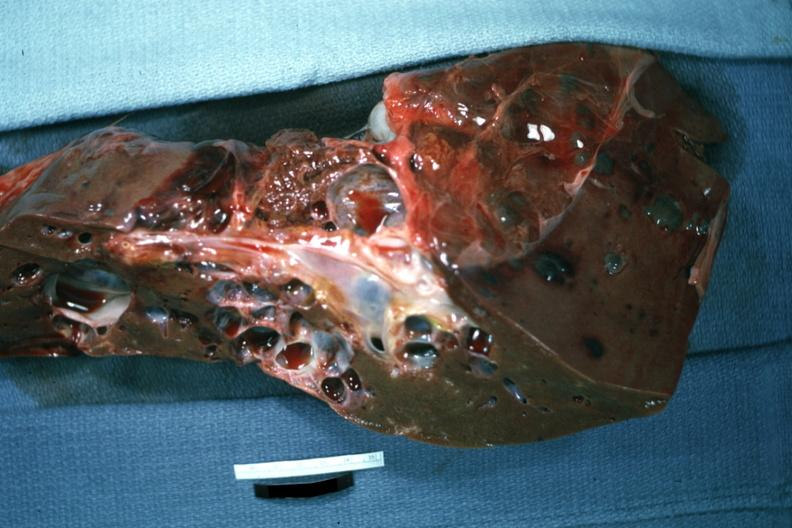what does this image show?
Answer the question using a single word or phrase. Cut surface with many cysts case of polycystic disease 